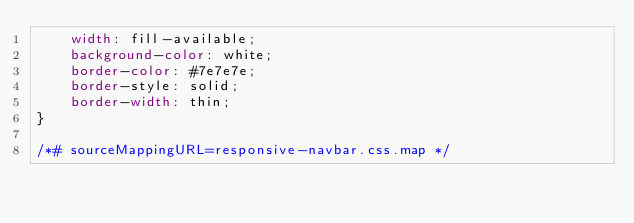<code> <loc_0><loc_0><loc_500><loc_500><_CSS_>    width: fill-available;
    background-color: white;
    border-color: #7e7e7e;
    border-style: solid;
    border-width: thin;
}

/*# sourceMappingURL=responsive-navbar.css.map */
</code> 